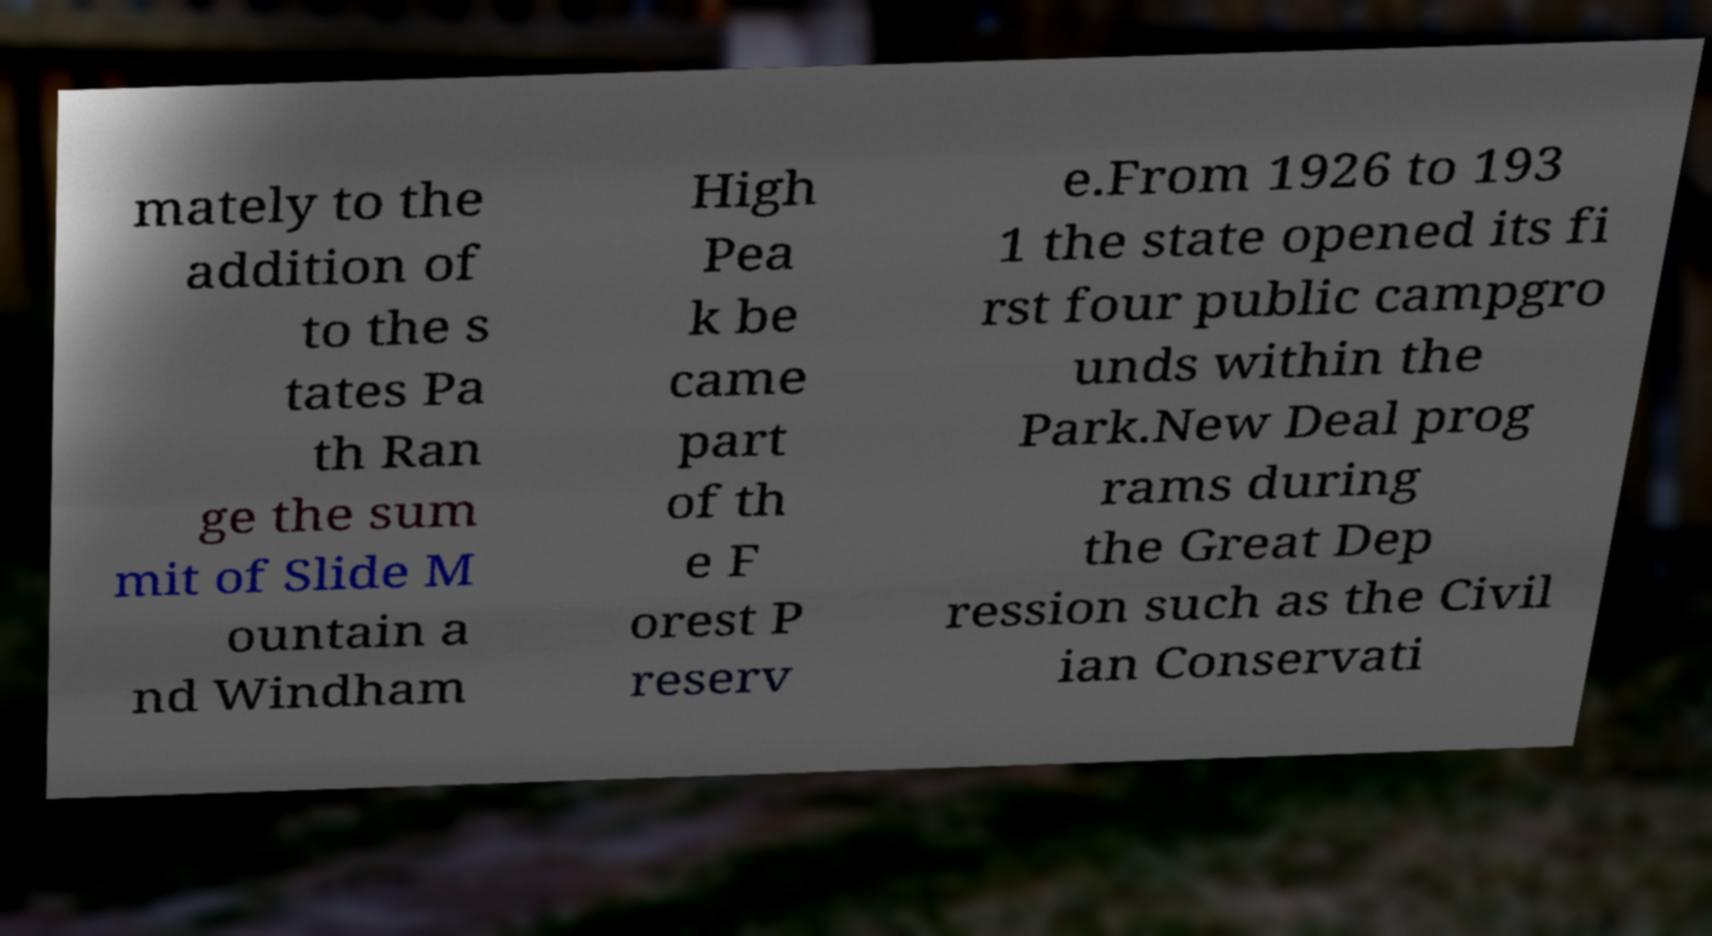For documentation purposes, I need the text within this image transcribed. Could you provide that? mately to the addition of to the s tates Pa th Ran ge the sum mit of Slide M ountain a nd Windham High Pea k be came part of th e F orest P reserv e.From 1926 to 193 1 the state opened its fi rst four public campgro unds within the Park.New Deal prog rams during the Great Dep ression such as the Civil ian Conservati 